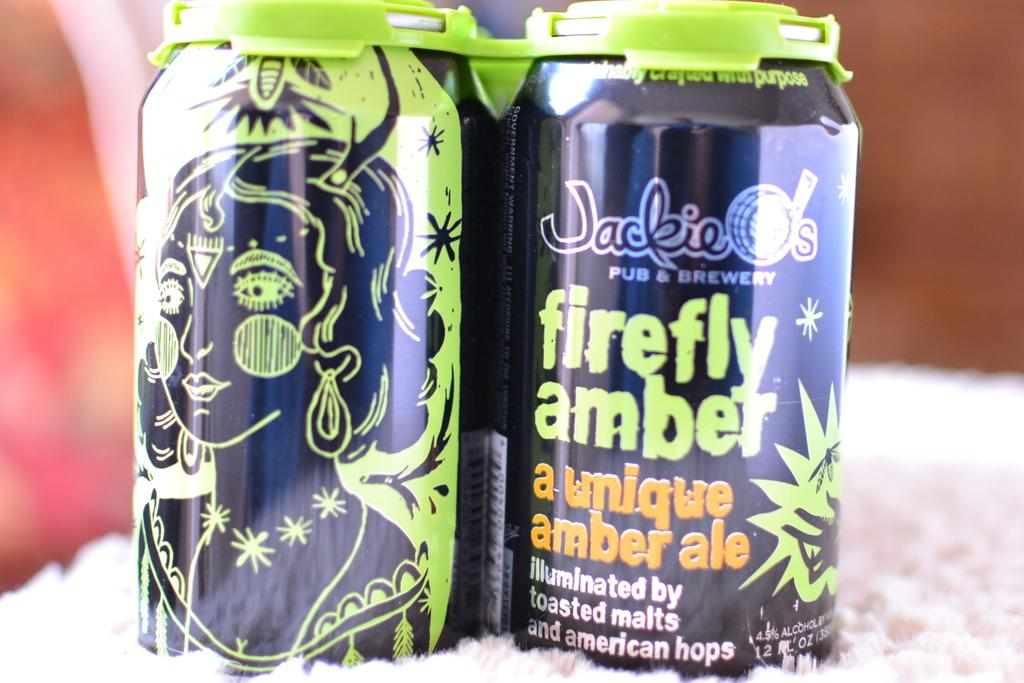<image>
Give a short and clear explanation of the subsequent image. Two cans of firefly amber are next to each other. 